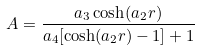<formula> <loc_0><loc_0><loc_500><loc_500>A = \frac { a _ { 3 } \cosh ( a _ { 2 } r ) } { a _ { 4 } [ \cosh ( a _ { 2 } r ) - 1 ] + 1 }</formula> 